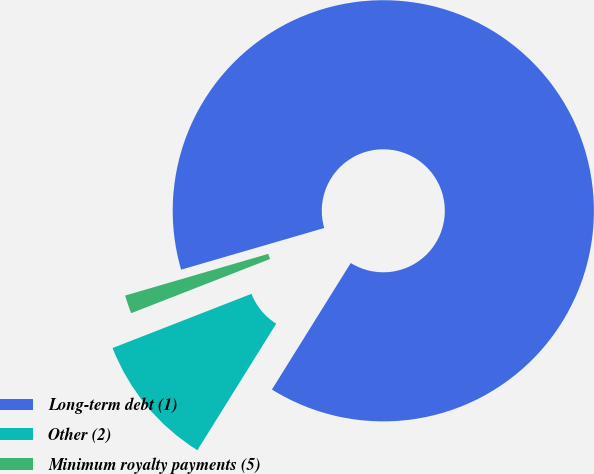Convert chart to OTSL. <chart><loc_0><loc_0><loc_500><loc_500><pie_chart><fcel>Long-term debt (1)<fcel>Other (2)<fcel>Minimum royalty payments (5)<nl><fcel>88.38%<fcel>10.21%<fcel>1.41%<nl></chart> 